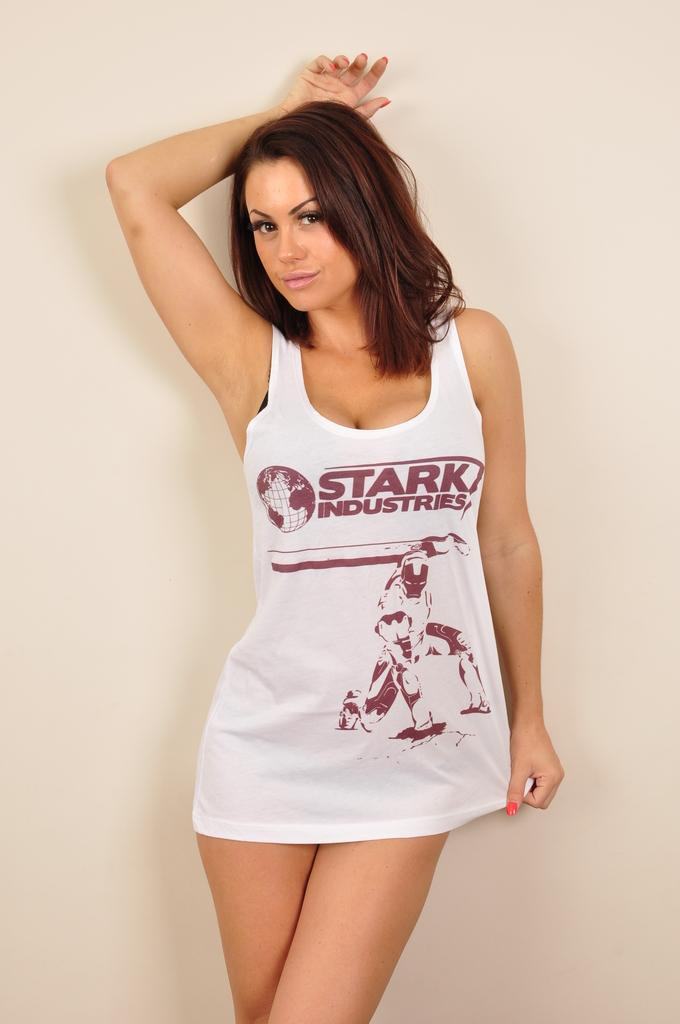<image>
Relay a brief, clear account of the picture shown. A female model with a Stark Industries shirt on 